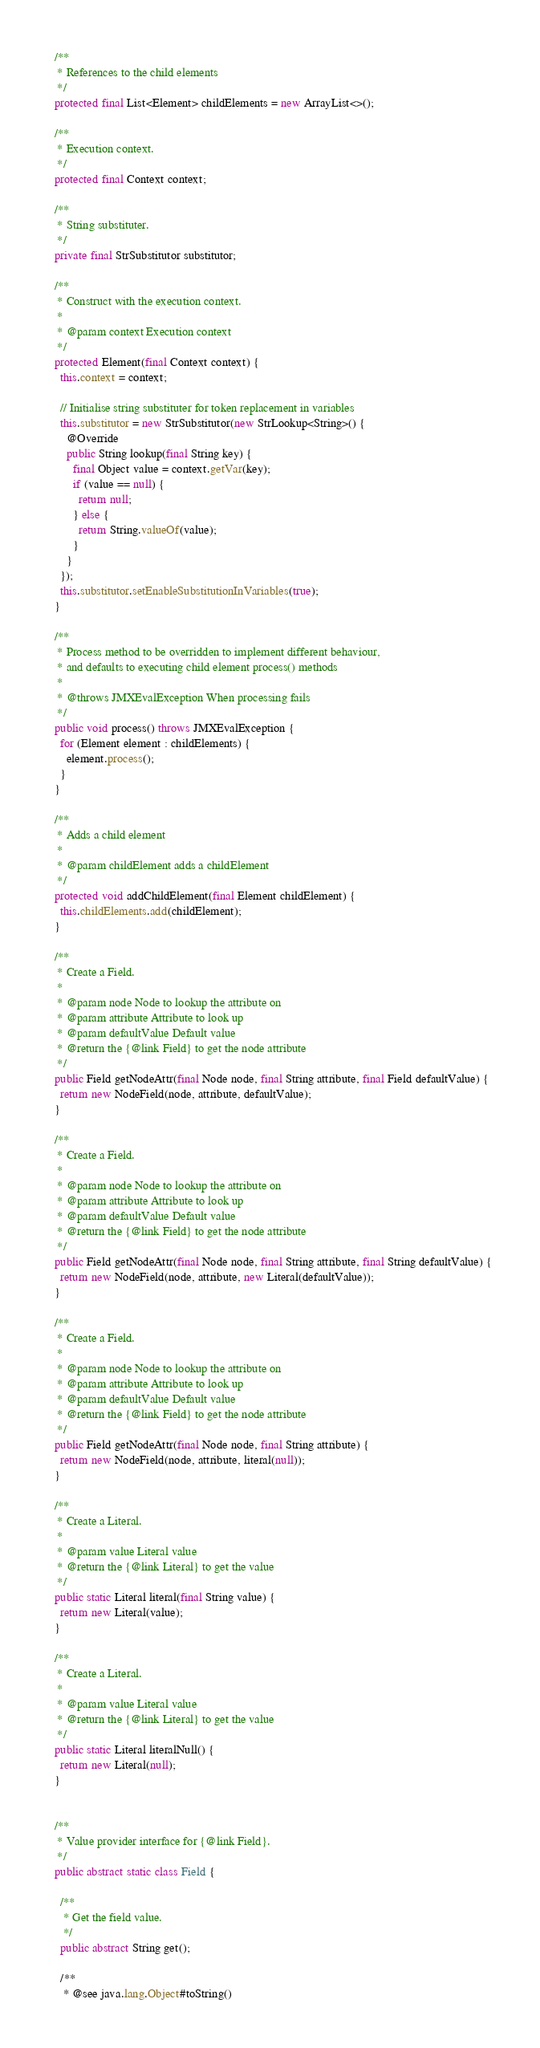Convert code to text. <code><loc_0><loc_0><loc_500><loc_500><_Java_>
  /**
   * References to the child elements
   */
  protected final List<Element> childElements = new ArrayList<>();

  /**
   * Execution context.
   */
  protected final Context context;

  /**
   * String substituter.
   */
  private final StrSubstitutor substitutor;

  /**
   * Construct with the execution context.
   *
   * @param context Execution context
   */
  protected Element(final Context context) {
    this.context = context;

    // Initialise string substituter for token replacement in variables
    this.substitutor = new StrSubstitutor(new StrLookup<String>() {
      @Override
      public String lookup(final String key) {
        final Object value = context.getVar(key);
        if (value == null) {
          return null;
        } else {
          return String.valueOf(value);
        }
      }
    });
    this.substitutor.setEnableSubstitutionInVariables(true);
  }

  /**
   * Process method to be overridden to implement different behaviour,
   * and defaults to executing child element process() methods
   *
   * @throws JMXEvalException When processing fails
   */
  public void process() throws JMXEvalException {
    for (Element element : childElements) {
      element.process();
    }
  }

  /**
   * Adds a child element
   *
   * @param childElement adds a childElement
   */
  protected void addChildElement(final Element childElement) {
    this.childElements.add(childElement);
  }

  /**
   * Create a Field.
   *
   * @param node Node to lookup the attribute on
   * @param attribute Attribute to look up
   * @param defaultValue Default value
   * @return the {@link Field} to get the node attribute
   */
  public Field getNodeAttr(final Node node, final String attribute, final Field defaultValue) {
    return new NodeField(node, attribute, defaultValue);
  }

  /**
   * Create a Field.
   *
   * @param node Node to lookup the attribute on
   * @param attribute Attribute to look up
   * @param defaultValue Default value
   * @return the {@link Field} to get the node attribute
   */
  public Field getNodeAttr(final Node node, final String attribute, final String defaultValue) {
    return new NodeField(node, attribute, new Literal(defaultValue));
  }

  /**
   * Create a Field.
   *
   * @param node Node to lookup the attribute on
   * @param attribute Attribute to look up
   * @param defaultValue Default value
   * @return the {@link Field} to get the node attribute
   */
  public Field getNodeAttr(final Node node, final String attribute) {
    return new NodeField(node, attribute, literal(null));
  }

  /**
   * Create a Literal.
   *
   * @param value Literal value
   * @return the {@link Literal} to get the value
   */
  public static Literal literal(final String value) {
    return new Literal(value);
  }

  /**
   * Create a Literal.
   *
   * @param value Literal value
   * @return the {@link Literal} to get the value
   */
  public static Literal literalNull() {
    return new Literal(null);
  }


  /**
   * Value provider interface for {@link Field}.
   */
  public abstract static class Field {

    /**
     * Get the field value.
     */
    public abstract String get();

    /**
     * @see java.lang.Object#toString()</code> 